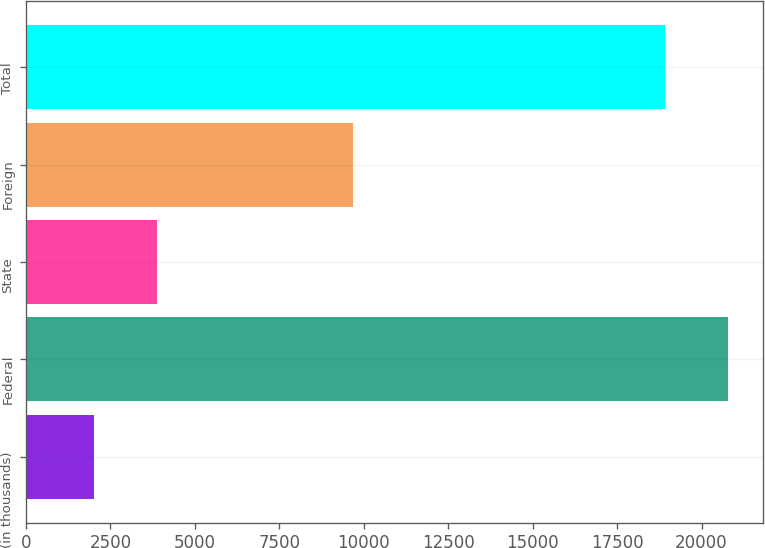<chart> <loc_0><loc_0><loc_500><loc_500><bar_chart><fcel>(in thousands)<fcel>Federal<fcel>State<fcel>Foreign<fcel>Total<nl><fcel>2006<fcel>20772.7<fcel>3873.7<fcel>9686<fcel>18905<nl></chart> 